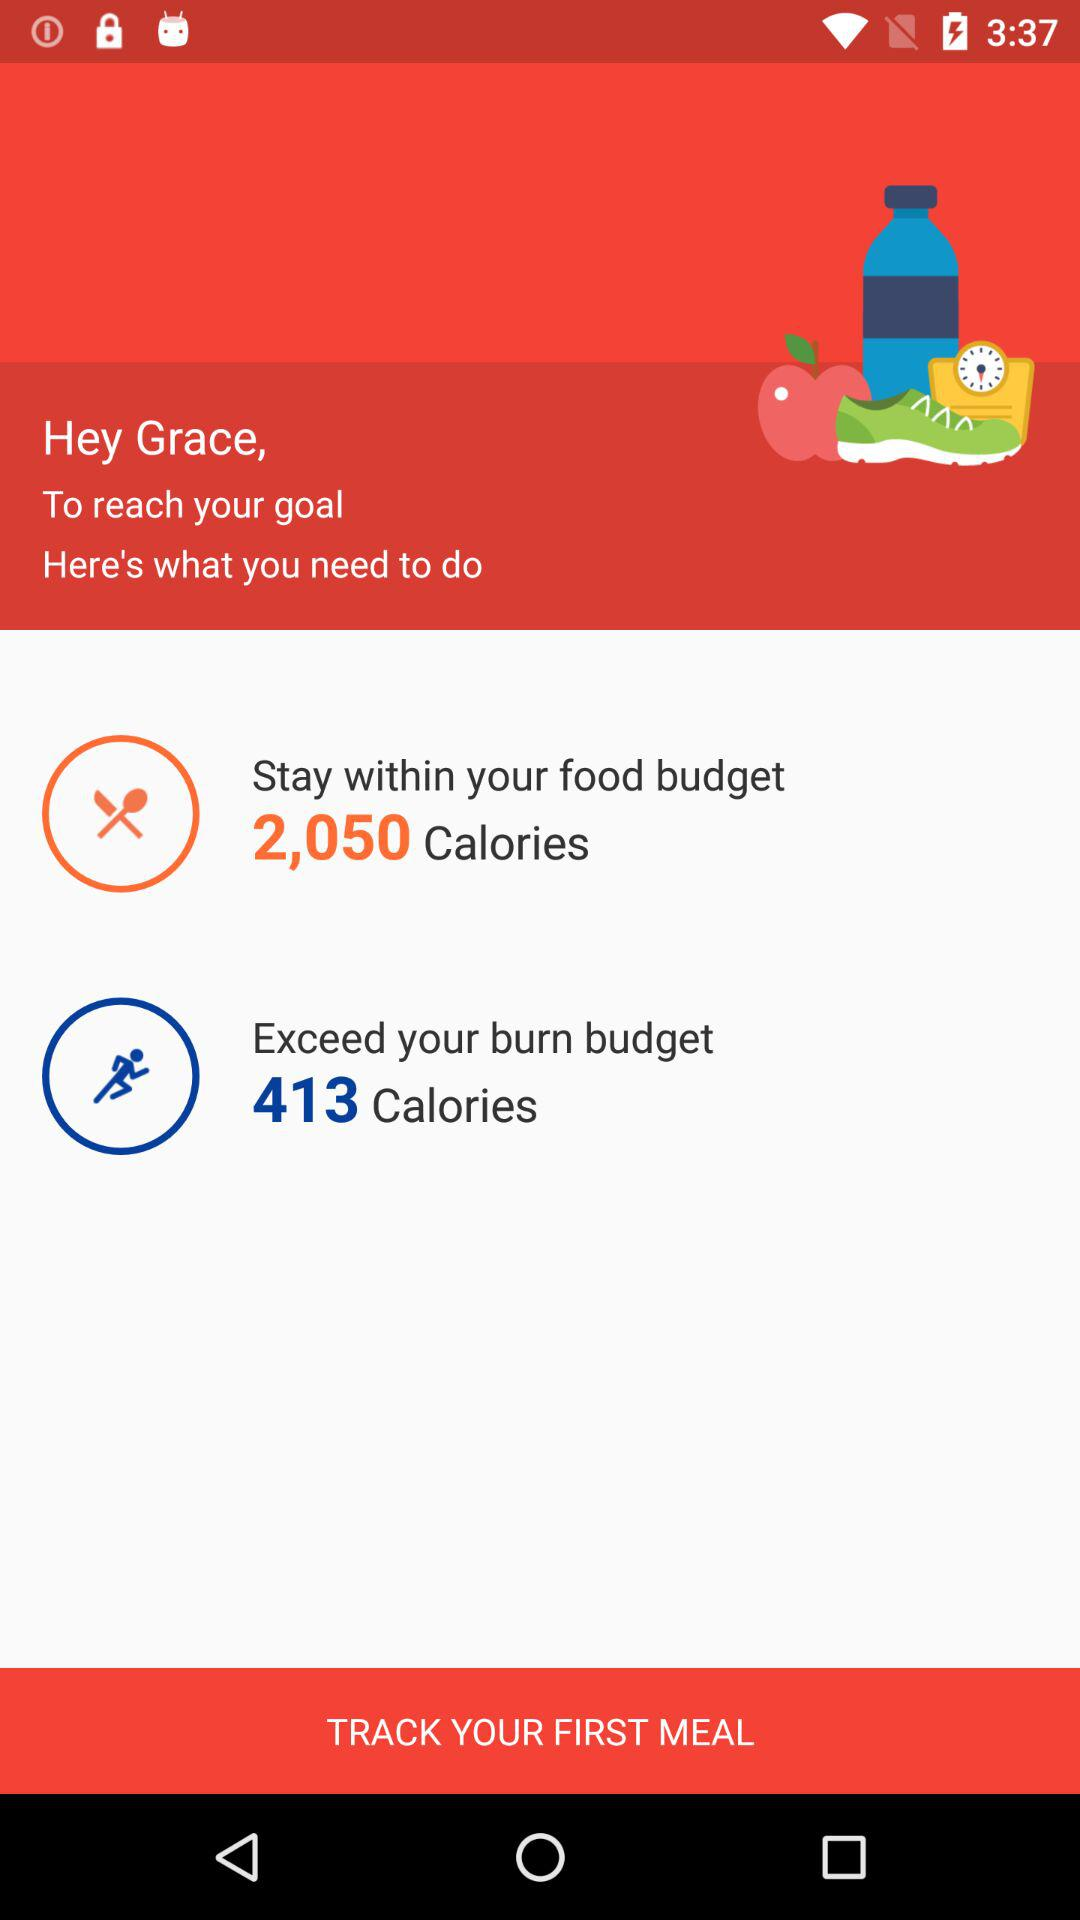How many calories do I need to stay within my food budget?
Answer the question using a single word or phrase. 2,050 